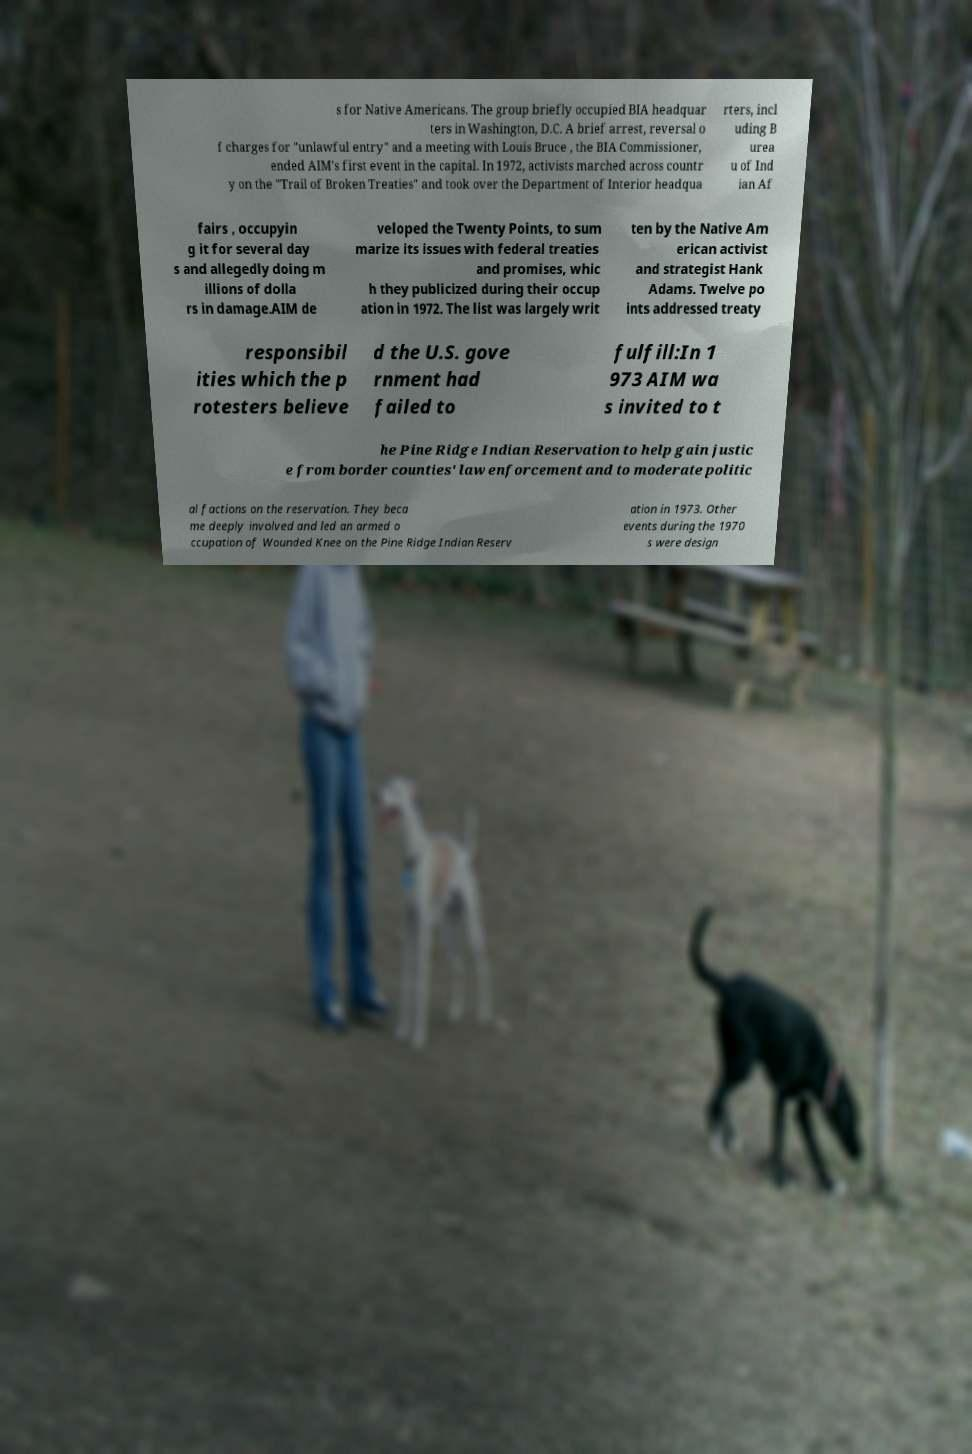Please identify and transcribe the text found in this image. s for Native Americans. The group briefly occupied BIA headquar ters in Washington, D.C. A brief arrest, reversal o f charges for "unlawful entry" and a meeting with Louis Bruce , the BIA Commissioner, ended AIM's first event in the capital. In 1972, activists marched across countr y on the "Trail of Broken Treaties" and took over the Department of Interior headqua rters, incl uding B urea u of Ind ian Af fairs , occupyin g it for several day s and allegedly doing m illions of dolla rs in damage.AIM de veloped the Twenty Points, to sum marize its issues with federal treaties and promises, whic h they publicized during their occup ation in 1972. The list was largely writ ten by the Native Am erican activist and strategist Hank Adams. Twelve po ints addressed treaty responsibil ities which the p rotesters believe d the U.S. gove rnment had failed to fulfill:In 1 973 AIM wa s invited to t he Pine Ridge Indian Reservation to help gain justic e from border counties' law enforcement and to moderate politic al factions on the reservation. They beca me deeply involved and led an armed o ccupation of Wounded Knee on the Pine Ridge Indian Reserv ation in 1973. Other events during the 1970 s were design 